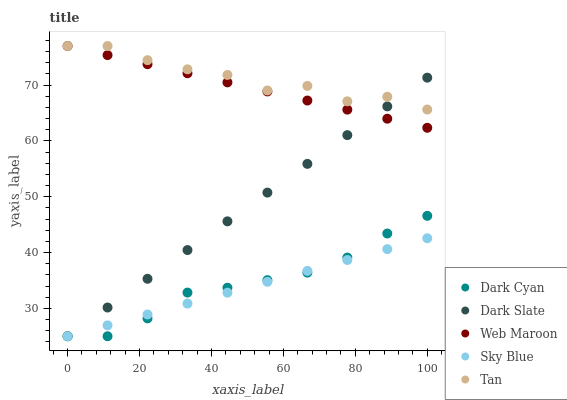Does Sky Blue have the minimum area under the curve?
Answer yes or no. Yes. Does Tan have the maximum area under the curve?
Answer yes or no. Yes. Does Dark Slate have the minimum area under the curve?
Answer yes or no. No. Does Dark Slate have the maximum area under the curve?
Answer yes or no. No. Is Dark Slate the smoothest?
Answer yes or no. Yes. Is Tan the roughest?
Answer yes or no. Yes. Is Tan the smoothest?
Answer yes or no. No. Is Dark Slate the roughest?
Answer yes or no. No. Does Dark Cyan have the lowest value?
Answer yes or no. Yes. Does Tan have the lowest value?
Answer yes or no. No. Does Web Maroon have the highest value?
Answer yes or no. Yes. Does Dark Slate have the highest value?
Answer yes or no. No. Is Dark Cyan less than Tan?
Answer yes or no. Yes. Is Tan greater than Sky Blue?
Answer yes or no. Yes. Does Dark Slate intersect Tan?
Answer yes or no. Yes. Is Dark Slate less than Tan?
Answer yes or no. No. Is Dark Slate greater than Tan?
Answer yes or no. No. Does Dark Cyan intersect Tan?
Answer yes or no. No. 